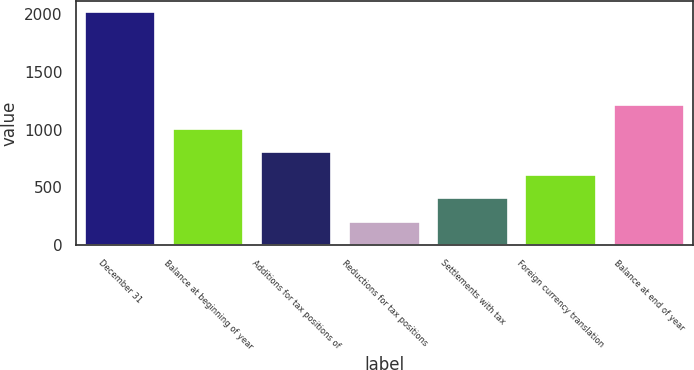<chart> <loc_0><loc_0><loc_500><loc_500><bar_chart><fcel>December 31<fcel>Balance at beginning of year<fcel>Additions for tax positions of<fcel>Reductions for tax positions<fcel>Settlements with tax<fcel>Foreign currency translation<fcel>Balance at end of year<nl><fcel>2015<fcel>1008.5<fcel>807.2<fcel>203.3<fcel>404.6<fcel>605.9<fcel>1209.8<nl></chart> 